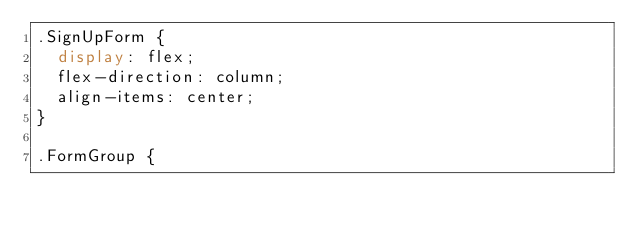Convert code to text. <code><loc_0><loc_0><loc_500><loc_500><_CSS_>.SignUpForm {
  display: flex;
  flex-direction: column;
  align-items: center;
}

.FormGroup {</code> 